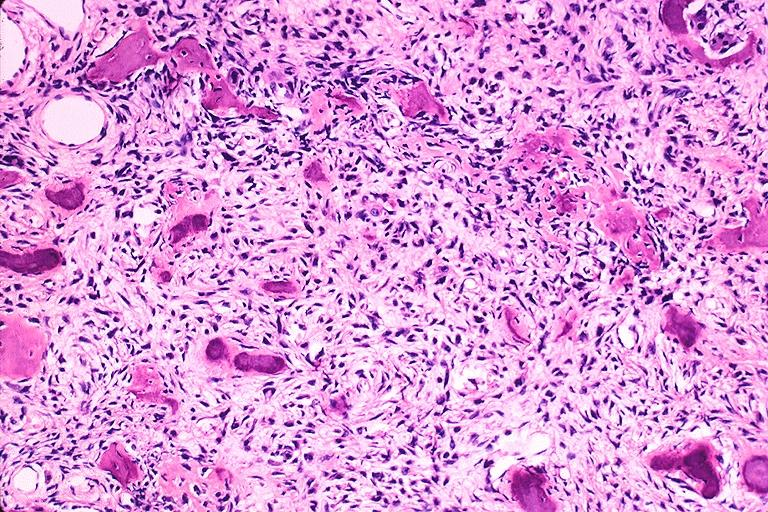does this image show cemento-ossifying fibroma?
Answer the question using a single word or phrase. Yes 